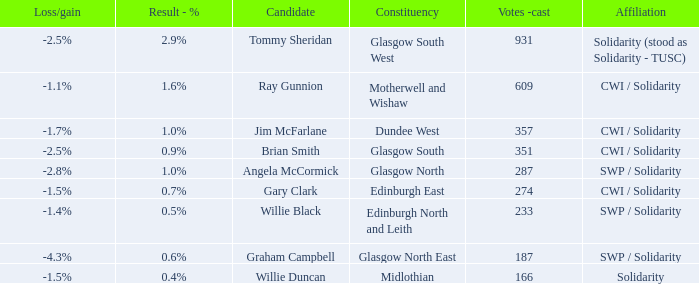What was the loss/gain when the affiliation was solidarity? -1.5%. Can you give me this table as a dict? {'header': ['Loss/gain', 'Result - %', 'Candidate', 'Constituency', 'Votes -cast', 'Affiliation'], 'rows': [['-2.5%', '2.9%', 'Tommy Sheridan', 'Glasgow South West', '931', 'Solidarity (stood as Solidarity - TUSC)'], ['-1.1%', '1.6%', 'Ray Gunnion', 'Motherwell and Wishaw', '609', 'CWI / Solidarity'], ['-1.7%', '1.0%', 'Jim McFarlane', 'Dundee West', '357', 'CWI / Solidarity'], ['-2.5%', '0.9%', 'Brian Smith', 'Glasgow South', '351', 'CWI / Solidarity'], ['-2.8%', '1.0%', 'Angela McCormick', 'Glasgow North', '287', 'SWP / Solidarity'], ['-1.5%', '0.7%', 'Gary Clark', 'Edinburgh East', '274', 'CWI / Solidarity'], ['-1.4%', '0.5%', 'Willie Black', 'Edinburgh North and Leith', '233', 'SWP / Solidarity'], ['-4.3%', '0.6%', 'Graham Campbell', 'Glasgow North East', '187', 'SWP / Solidarity'], ['-1.5%', '0.4%', 'Willie Duncan', 'Midlothian', '166', 'Solidarity']]} 